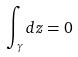Convert formula to latex. <formula><loc_0><loc_0><loc_500><loc_500>\int _ { \gamma } d z = 0</formula> 